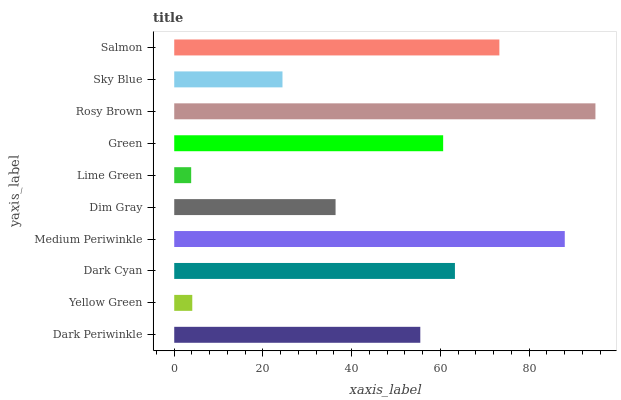Is Lime Green the minimum?
Answer yes or no. Yes. Is Rosy Brown the maximum?
Answer yes or no. Yes. Is Yellow Green the minimum?
Answer yes or no. No. Is Yellow Green the maximum?
Answer yes or no. No. Is Dark Periwinkle greater than Yellow Green?
Answer yes or no. Yes. Is Yellow Green less than Dark Periwinkle?
Answer yes or no. Yes. Is Yellow Green greater than Dark Periwinkle?
Answer yes or no. No. Is Dark Periwinkle less than Yellow Green?
Answer yes or no. No. Is Green the high median?
Answer yes or no. Yes. Is Dark Periwinkle the low median?
Answer yes or no. Yes. Is Yellow Green the high median?
Answer yes or no. No. Is Lime Green the low median?
Answer yes or no. No. 